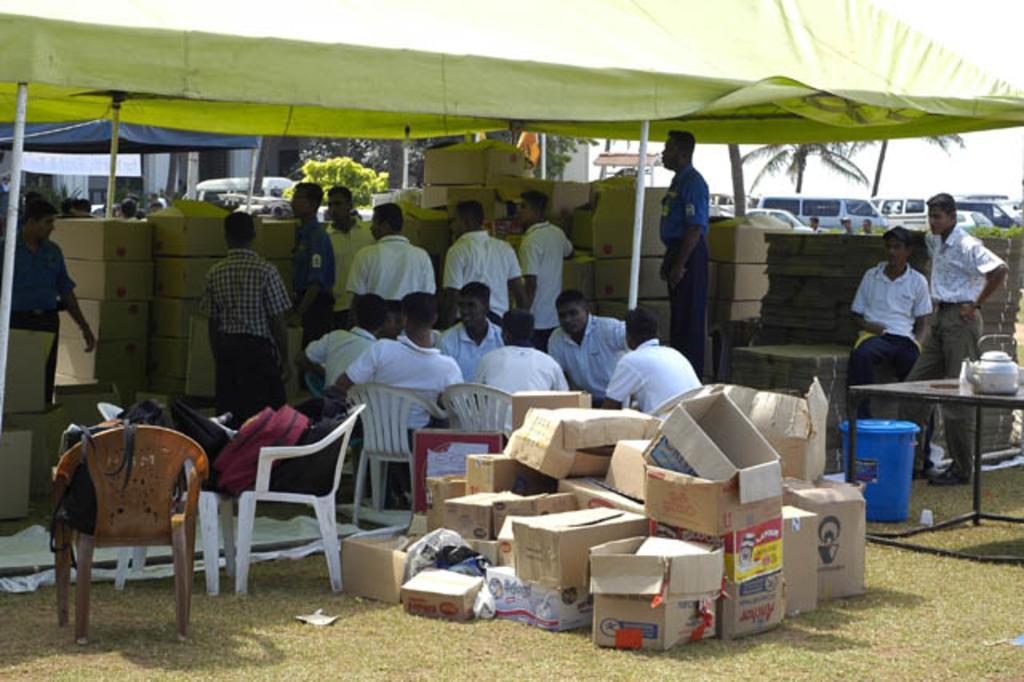Describe this image in one or two sentences. In the picture I can see cardboard boxes, bags kept on the chairs, few people sitting on the chairs, we can see blue color tub, a kettle is placed on a table, a few people standing, we can see tents, cardboard boxes placed here, we can see vehicles parked there, we can see trees and the sky in the background. 